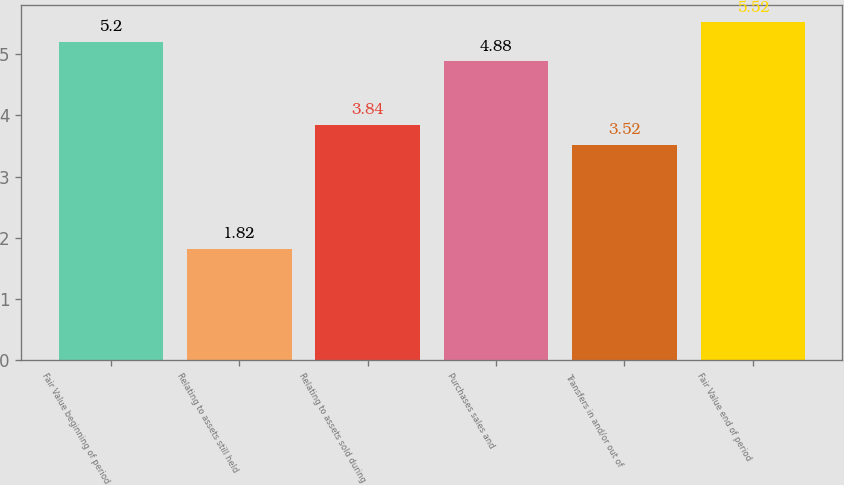Convert chart to OTSL. <chart><loc_0><loc_0><loc_500><loc_500><bar_chart><fcel>Fair Value beginning of period<fcel>Relating to assets still held<fcel>Relating to assets sold during<fcel>Purchases sales and<fcel>Transfers in and/or out of<fcel>Fair Value end of period<nl><fcel>5.2<fcel>1.82<fcel>3.84<fcel>4.88<fcel>3.52<fcel>5.52<nl></chart> 